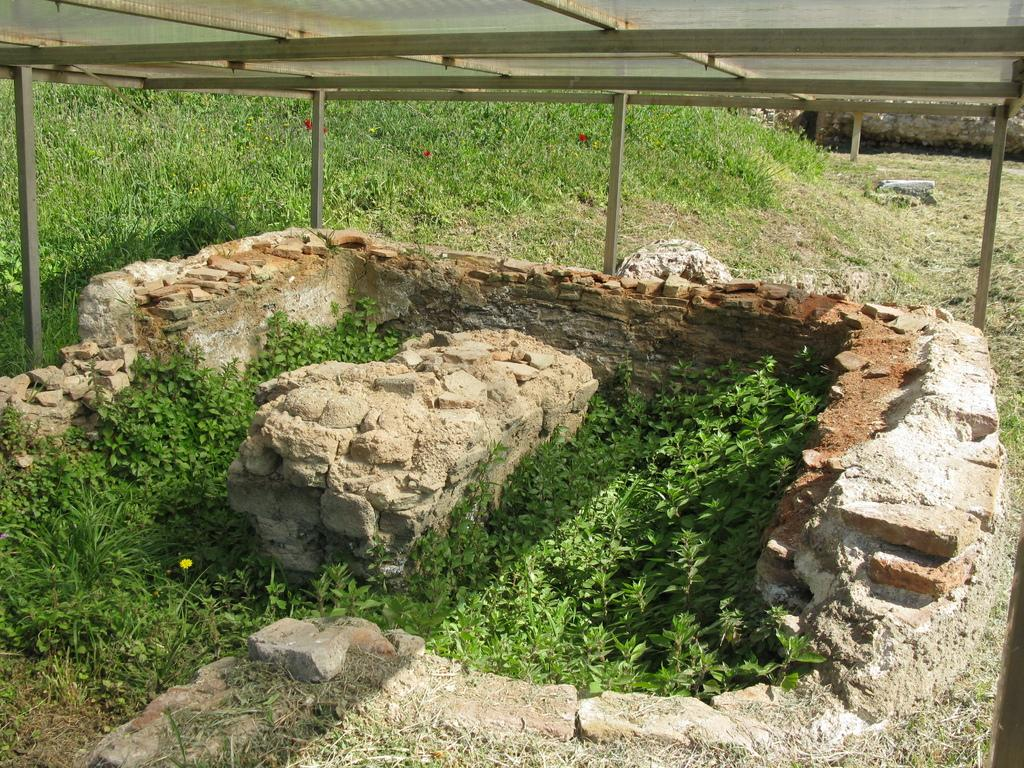What type of structure is visible in the image? There is a brick wall in the image. What is growing on the wall? Plants are present on all sides of the wall. What type of vegetation is visible on the land surrounding the wall? Grass is visible on the land surrounding the wall. What is above the wall? There is a roof above the wall. How many worms can be seen crawling on the roof in the image? There are no worms visible in the image; the focus is on the brick wall, plants, and grass. 